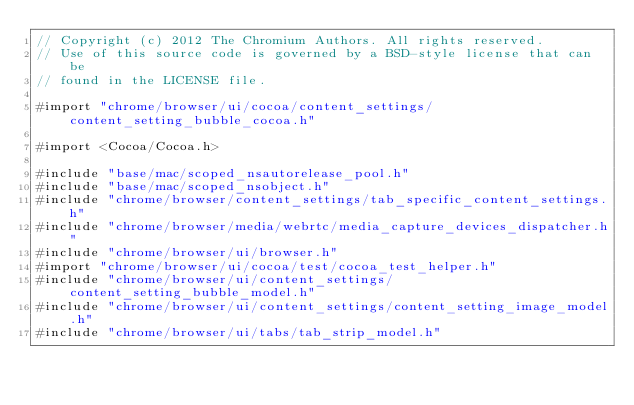Convert code to text. <code><loc_0><loc_0><loc_500><loc_500><_ObjectiveC_>// Copyright (c) 2012 The Chromium Authors. All rights reserved.
// Use of this source code is governed by a BSD-style license that can be
// found in the LICENSE file.

#import "chrome/browser/ui/cocoa/content_settings/content_setting_bubble_cocoa.h"

#import <Cocoa/Cocoa.h>

#include "base/mac/scoped_nsautorelease_pool.h"
#include "base/mac/scoped_nsobject.h"
#include "chrome/browser/content_settings/tab_specific_content_settings.h"
#include "chrome/browser/media/webrtc/media_capture_devices_dispatcher.h"
#include "chrome/browser/ui/browser.h"
#import "chrome/browser/ui/cocoa/test/cocoa_test_helper.h"
#include "chrome/browser/ui/content_settings/content_setting_bubble_model.h"
#include "chrome/browser/ui/content_settings/content_setting_image_model.h"
#include "chrome/browser/ui/tabs/tab_strip_model.h"</code> 